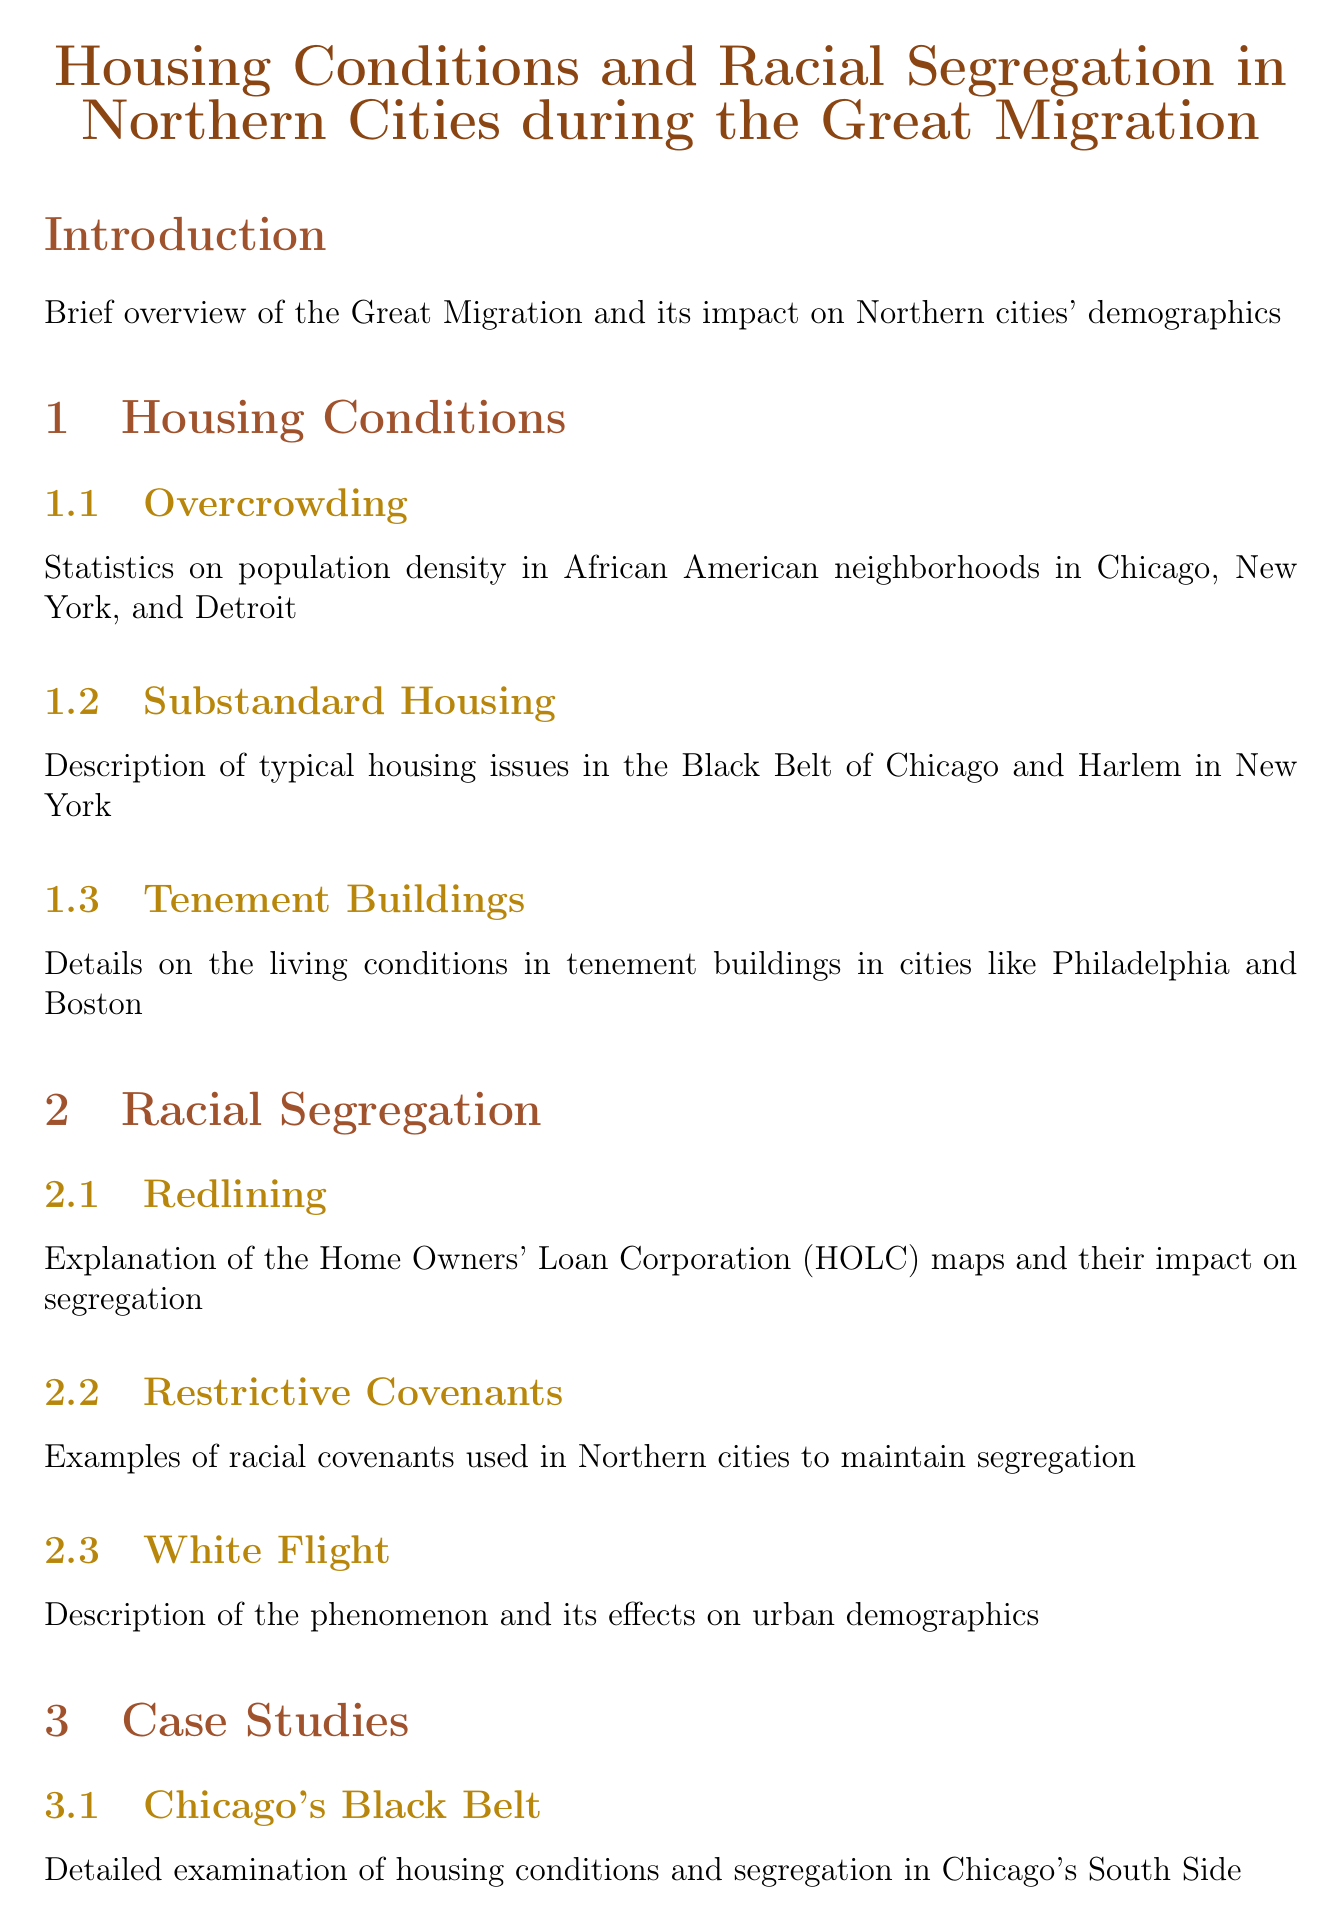What is the title of the report? The title of the report provides the main subject matter, summarizing its focus and scope.
Answer: Housing Conditions and Racial Segregation in Northern Cities during the Great Migration What year is the HOLC map of Brooklyn from? The year indicates the specific timing of the data presented on the map and its relevance to the historical context.
Answer: 1938 Which city is associated with the term "Black Belt"? This term is used to refer specifically to a region characterized by particular demographic and housing conditions in a city.
Answer: Chicago What were the main housing issues in Harlem, according to the report? Identifying the specific problems discussed gives insight into the living conditions faced by African American migrants in that area.
Answer: Substandard Housing What is the focus of the case study on Harlem, New York? This question seeks to understand what aspect of Harlem's housing and demographics the report examines in detail.
Answer: Transformation during the Great Migration Who authored the book "Black Metropolis"? This information provides an important reference for the primary sources section, highlighting key works relevant to the study.
Answer: St. Clair Drake and Horace R. Cayton What was a common issue faced by tenement buildings in Philadelphia? This question prompts for specific problematic aspects detailed in the section on tenement conditions.
Answer: Overcrowding What phenomenon describes the effects of demographic shifts caused by white residents moving out? Understanding this term helps clarify the broader implications of racial dynamics in urban settings.
Answer: White Flight Which photographer captured an interior of a tenement in Harlem? This question connects specific visual documentation with its author to enhance the historical context of the images presented.
Answer: Arnold Eagle 